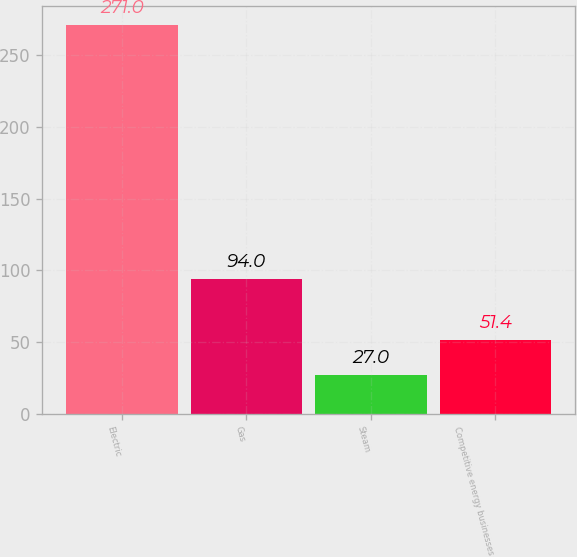<chart> <loc_0><loc_0><loc_500><loc_500><bar_chart><fcel>Electric<fcel>Gas<fcel>Steam<fcel>Competitive energy businesses<nl><fcel>271<fcel>94<fcel>27<fcel>51.4<nl></chart> 